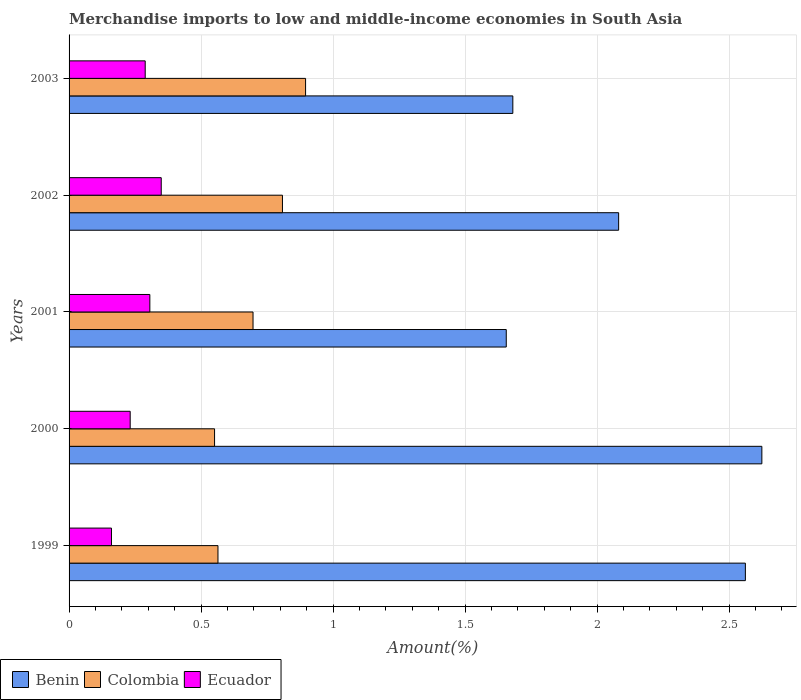How many different coloured bars are there?
Your response must be concise. 3. Are the number of bars per tick equal to the number of legend labels?
Your response must be concise. Yes. Are the number of bars on each tick of the Y-axis equal?
Offer a very short reply. Yes. How many bars are there on the 2nd tick from the bottom?
Give a very brief answer. 3. What is the label of the 1st group of bars from the top?
Offer a terse response. 2003. What is the percentage of amount earned from merchandise imports in Colombia in 2001?
Offer a terse response. 0.7. Across all years, what is the maximum percentage of amount earned from merchandise imports in Ecuador?
Provide a succinct answer. 0.35. Across all years, what is the minimum percentage of amount earned from merchandise imports in Benin?
Offer a very short reply. 1.66. What is the total percentage of amount earned from merchandise imports in Benin in the graph?
Offer a terse response. 10.6. What is the difference between the percentage of amount earned from merchandise imports in Colombia in 1999 and that in 2000?
Make the answer very short. 0.01. What is the difference between the percentage of amount earned from merchandise imports in Colombia in 2003 and the percentage of amount earned from merchandise imports in Ecuador in 2002?
Keep it short and to the point. 0.55. What is the average percentage of amount earned from merchandise imports in Benin per year?
Your answer should be compact. 2.12. In the year 2001, what is the difference between the percentage of amount earned from merchandise imports in Benin and percentage of amount earned from merchandise imports in Colombia?
Provide a succinct answer. 0.96. What is the ratio of the percentage of amount earned from merchandise imports in Ecuador in 2001 to that in 2002?
Provide a short and direct response. 0.88. Is the percentage of amount earned from merchandise imports in Ecuador in 2000 less than that in 2003?
Ensure brevity in your answer.  Yes. Is the difference between the percentage of amount earned from merchandise imports in Benin in 2000 and 2003 greater than the difference between the percentage of amount earned from merchandise imports in Colombia in 2000 and 2003?
Your answer should be compact. Yes. What is the difference between the highest and the second highest percentage of amount earned from merchandise imports in Ecuador?
Give a very brief answer. 0.04. What is the difference between the highest and the lowest percentage of amount earned from merchandise imports in Benin?
Offer a very short reply. 0.97. In how many years, is the percentage of amount earned from merchandise imports in Benin greater than the average percentage of amount earned from merchandise imports in Benin taken over all years?
Your response must be concise. 2. Is the sum of the percentage of amount earned from merchandise imports in Colombia in 2000 and 2003 greater than the maximum percentage of amount earned from merchandise imports in Benin across all years?
Your response must be concise. No. What does the 1st bar from the top in 2001 represents?
Your answer should be very brief. Ecuador. What does the 3rd bar from the bottom in 2000 represents?
Provide a short and direct response. Ecuador. How many years are there in the graph?
Make the answer very short. 5. What is the difference between two consecutive major ticks on the X-axis?
Make the answer very short. 0.5. Does the graph contain grids?
Your answer should be compact. Yes. How are the legend labels stacked?
Provide a short and direct response. Horizontal. What is the title of the graph?
Offer a very short reply. Merchandise imports to low and middle-income economies in South Asia. Does "Mozambique" appear as one of the legend labels in the graph?
Your answer should be very brief. No. What is the label or title of the X-axis?
Keep it short and to the point. Amount(%). What is the label or title of the Y-axis?
Make the answer very short. Years. What is the Amount(%) of Benin in 1999?
Your answer should be compact. 2.56. What is the Amount(%) of Colombia in 1999?
Your answer should be very brief. 0.56. What is the Amount(%) in Ecuador in 1999?
Ensure brevity in your answer.  0.16. What is the Amount(%) in Benin in 2000?
Offer a very short reply. 2.62. What is the Amount(%) in Colombia in 2000?
Your answer should be very brief. 0.55. What is the Amount(%) in Ecuador in 2000?
Make the answer very short. 0.23. What is the Amount(%) in Benin in 2001?
Your answer should be very brief. 1.66. What is the Amount(%) in Colombia in 2001?
Your answer should be very brief. 0.7. What is the Amount(%) in Ecuador in 2001?
Offer a very short reply. 0.31. What is the Amount(%) of Benin in 2002?
Make the answer very short. 2.08. What is the Amount(%) in Colombia in 2002?
Your response must be concise. 0.81. What is the Amount(%) in Ecuador in 2002?
Keep it short and to the point. 0.35. What is the Amount(%) in Benin in 2003?
Offer a terse response. 1.68. What is the Amount(%) in Colombia in 2003?
Offer a terse response. 0.9. What is the Amount(%) in Ecuador in 2003?
Offer a terse response. 0.29. Across all years, what is the maximum Amount(%) in Benin?
Offer a terse response. 2.62. Across all years, what is the maximum Amount(%) in Colombia?
Ensure brevity in your answer.  0.9. Across all years, what is the maximum Amount(%) in Ecuador?
Ensure brevity in your answer.  0.35. Across all years, what is the minimum Amount(%) of Benin?
Provide a short and direct response. 1.66. Across all years, what is the minimum Amount(%) in Colombia?
Offer a very short reply. 0.55. Across all years, what is the minimum Amount(%) of Ecuador?
Provide a succinct answer. 0.16. What is the total Amount(%) in Benin in the graph?
Your answer should be compact. 10.6. What is the total Amount(%) of Colombia in the graph?
Provide a short and direct response. 3.52. What is the total Amount(%) of Ecuador in the graph?
Keep it short and to the point. 1.34. What is the difference between the Amount(%) in Benin in 1999 and that in 2000?
Provide a succinct answer. -0.06. What is the difference between the Amount(%) in Colombia in 1999 and that in 2000?
Your response must be concise. 0.01. What is the difference between the Amount(%) of Ecuador in 1999 and that in 2000?
Your answer should be very brief. -0.07. What is the difference between the Amount(%) of Benin in 1999 and that in 2001?
Offer a very short reply. 0.91. What is the difference between the Amount(%) of Colombia in 1999 and that in 2001?
Keep it short and to the point. -0.13. What is the difference between the Amount(%) in Ecuador in 1999 and that in 2001?
Keep it short and to the point. -0.15. What is the difference between the Amount(%) of Benin in 1999 and that in 2002?
Your response must be concise. 0.48. What is the difference between the Amount(%) of Colombia in 1999 and that in 2002?
Keep it short and to the point. -0.24. What is the difference between the Amount(%) of Ecuador in 1999 and that in 2002?
Make the answer very short. -0.19. What is the difference between the Amount(%) of Benin in 1999 and that in 2003?
Provide a short and direct response. 0.88. What is the difference between the Amount(%) of Colombia in 1999 and that in 2003?
Provide a succinct answer. -0.33. What is the difference between the Amount(%) of Ecuador in 1999 and that in 2003?
Provide a short and direct response. -0.13. What is the difference between the Amount(%) in Benin in 2000 and that in 2001?
Provide a short and direct response. 0.97. What is the difference between the Amount(%) of Colombia in 2000 and that in 2001?
Your answer should be compact. -0.15. What is the difference between the Amount(%) of Ecuador in 2000 and that in 2001?
Provide a short and direct response. -0.07. What is the difference between the Amount(%) of Benin in 2000 and that in 2002?
Offer a terse response. 0.54. What is the difference between the Amount(%) in Colombia in 2000 and that in 2002?
Your response must be concise. -0.26. What is the difference between the Amount(%) of Ecuador in 2000 and that in 2002?
Make the answer very short. -0.12. What is the difference between the Amount(%) of Benin in 2000 and that in 2003?
Ensure brevity in your answer.  0.94. What is the difference between the Amount(%) of Colombia in 2000 and that in 2003?
Give a very brief answer. -0.34. What is the difference between the Amount(%) in Ecuador in 2000 and that in 2003?
Your response must be concise. -0.06. What is the difference between the Amount(%) in Benin in 2001 and that in 2002?
Offer a very short reply. -0.43. What is the difference between the Amount(%) of Colombia in 2001 and that in 2002?
Give a very brief answer. -0.11. What is the difference between the Amount(%) in Ecuador in 2001 and that in 2002?
Provide a succinct answer. -0.04. What is the difference between the Amount(%) of Benin in 2001 and that in 2003?
Your answer should be very brief. -0.02. What is the difference between the Amount(%) in Colombia in 2001 and that in 2003?
Offer a terse response. -0.2. What is the difference between the Amount(%) of Ecuador in 2001 and that in 2003?
Provide a short and direct response. 0.02. What is the difference between the Amount(%) of Benin in 2002 and that in 2003?
Ensure brevity in your answer.  0.4. What is the difference between the Amount(%) in Colombia in 2002 and that in 2003?
Provide a short and direct response. -0.09. What is the difference between the Amount(%) of Ecuador in 2002 and that in 2003?
Your answer should be compact. 0.06. What is the difference between the Amount(%) in Benin in 1999 and the Amount(%) in Colombia in 2000?
Offer a terse response. 2.01. What is the difference between the Amount(%) of Benin in 1999 and the Amount(%) of Ecuador in 2000?
Your response must be concise. 2.33. What is the difference between the Amount(%) in Colombia in 1999 and the Amount(%) in Ecuador in 2000?
Your answer should be very brief. 0.33. What is the difference between the Amount(%) of Benin in 1999 and the Amount(%) of Colombia in 2001?
Provide a succinct answer. 1.86. What is the difference between the Amount(%) of Benin in 1999 and the Amount(%) of Ecuador in 2001?
Offer a terse response. 2.26. What is the difference between the Amount(%) in Colombia in 1999 and the Amount(%) in Ecuador in 2001?
Your answer should be very brief. 0.26. What is the difference between the Amount(%) of Benin in 1999 and the Amount(%) of Colombia in 2002?
Provide a succinct answer. 1.75. What is the difference between the Amount(%) in Benin in 1999 and the Amount(%) in Ecuador in 2002?
Offer a very short reply. 2.21. What is the difference between the Amount(%) in Colombia in 1999 and the Amount(%) in Ecuador in 2002?
Offer a very short reply. 0.21. What is the difference between the Amount(%) in Benin in 1999 and the Amount(%) in Colombia in 2003?
Ensure brevity in your answer.  1.67. What is the difference between the Amount(%) in Benin in 1999 and the Amount(%) in Ecuador in 2003?
Offer a very short reply. 2.27. What is the difference between the Amount(%) in Colombia in 1999 and the Amount(%) in Ecuador in 2003?
Your answer should be very brief. 0.28. What is the difference between the Amount(%) in Benin in 2000 and the Amount(%) in Colombia in 2001?
Keep it short and to the point. 1.93. What is the difference between the Amount(%) in Benin in 2000 and the Amount(%) in Ecuador in 2001?
Offer a terse response. 2.32. What is the difference between the Amount(%) of Colombia in 2000 and the Amount(%) of Ecuador in 2001?
Offer a terse response. 0.25. What is the difference between the Amount(%) in Benin in 2000 and the Amount(%) in Colombia in 2002?
Your answer should be very brief. 1.82. What is the difference between the Amount(%) of Benin in 2000 and the Amount(%) of Ecuador in 2002?
Give a very brief answer. 2.27. What is the difference between the Amount(%) of Colombia in 2000 and the Amount(%) of Ecuador in 2002?
Provide a short and direct response. 0.2. What is the difference between the Amount(%) in Benin in 2000 and the Amount(%) in Colombia in 2003?
Your answer should be compact. 1.73. What is the difference between the Amount(%) in Benin in 2000 and the Amount(%) in Ecuador in 2003?
Your answer should be compact. 2.34. What is the difference between the Amount(%) in Colombia in 2000 and the Amount(%) in Ecuador in 2003?
Provide a short and direct response. 0.26. What is the difference between the Amount(%) in Benin in 2001 and the Amount(%) in Colombia in 2002?
Give a very brief answer. 0.85. What is the difference between the Amount(%) of Benin in 2001 and the Amount(%) of Ecuador in 2002?
Offer a terse response. 1.31. What is the difference between the Amount(%) in Colombia in 2001 and the Amount(%) in Ecuador in 2002?
Provide a succinct answer. 0.35. What is the difference between the Amount(%) in Benin in 2001 and the Amount(%) in Colombia in 2003?
Keep it short and to the point. 0.76. What is the difference between the Amount(%) in Benin in 2001 and the Amount(%) in Ecuador in 2003?
Offer a very short reply. 1.37. What is the difference between the Amount(%) in Colombia in 2001 and the Amount(%) in Ecuador in 2003?
Your answer should be very brief. 0.41. What is the difference between the Amount(%) in Benin in 2002 and the Amount(%) in Colombia in 2003?
Ensure brevity in your answer.  1.19. What is the difference between the Amount(%) of Benin in 2002 and the Amount(%) of Ecuador in 2003?
Make the answer very short. 1.79. What is the difference between the Amount(%) in Colombia in 2002 and the Amount(%) in Ecuador in 2003?
Offer a terse response. 0.52. What is the average Amount(%) of Benin per year?
Your response must be concise. 2.12. What is the average Amount(%) of Colombia per year?
Offer a terse response. 0.7. What is the average Amount(%) of Ecuador per year?
Offer a terse response. 0.27. In the year 1999, what is the difference between the Amount(%) of Benin and Amount(%) of Colombia?
Provide a succinct answer. 2. In the year 1999, what is the difference between the Amount(%) of Benin and Amount(%) of Ecuador?
Your response must be concise. 2.4. In the year 1999, what is the difference between the Amount(%) in Colombia and Amount(%) in Ecuador?
Your response must be concise. 0.4. In the year 2000, what is the difference between the Amount(%) of Benin and Amount(%) of Colombia?
Your answer should be compact. 2.07. In the year 2000, what is the difference between the Amount(%) in Benin and Amount(%) in Ecuador?
Provide a short and direct response. 2.39. In the year 2000, what is the difference between the Amount(%) of Colombia and Amount(%) of Ecuador?
Ensure brevity in your answer.  0.32. In the year 2001, what is the difference between the Amount(%) of Benin and Amount(%) of Ecuador?
Ensure brevity in your answer.  1.35. In the year 2001, what is the difference between the Amount(%) in Colombia and Amount(%) in Ecuador?
Offer a terse response. 0.39. In the year 2002, what is the difference between the Amount(%) in Benin and Amount(%) in Colombia?
Give a very brief answer. 1.27. In the year 2002, what is the difference between the Amount(%) of Benin and Amount(%) of Ecuador?
Ensure brevity in your answer.  1.73. In the year 2002, what is the difference between the Amount(%) in Colombia and Amount(%) in Ecuador?
Make the answer very short. 0.46. In the year 2003, what is the difference between the Amount(%) of Benin and Amount(%) of Colombia?
Your answer should be very brief. 0.78. In the year 2003, what is the difference between the Amount(%) in Benin and Amount(%) in Ecuador?
Your answer should be very brief. 1.39. In the year 2003, what is the difference between the Amount(%) in Colombia and Amount(%) in Ecuador?
Offer a terse response. 0.61. What is the ratio of the Amount(%) in Benin in 1999 to that in 2000?
Provide a short and direct response. 0.98. What is the ratio of the Amount(%) of Colombia in 1999 to that in 2000?
Offer a terse response. 1.02. What is the ratio of the Amount(%) in Ecuador in 1999 to that in 2000?
Offer a very short reply. 0.69. What is the ratio of the Amount(%) of Benin in 1999 to that in 2001?
Provide a short and direct response. 1.55. What is the ratio of the Amount(%) of Colombia in 1999 to that in 2001?
Provide a succinct answer. 0.81. What is the ratio of the Amount(%) in Ecuador in 1999 to that in 2001?
Ensure brevity in your answer.  0.52. What is the ratio of the Amount(%) in Benin in 1999 to that in 2002?
Provide a succinct answer. 1.23. What is the ratio of the Amount(%) of Colombia in 1999 to that in 2002?
Offer a very short reply. 0.7. What is the ratio of the Amount(%) in Ecuador in 1999 to that in 2002?
Provide a short and direct response. 0.46. What is the ratio of the Amount(%) of Benin in 1999 to that in 2003?
Ensure brevity in your answer.  1.52. What is the ratio of the Amount(%) in Colombia in 1999 to that in 2003?
Provide a short and direct response. 0.63. What is the ratio of the Amount(%) in Ecuador in 1999 to that in 2003?
Give a very brief answer. 0.56. What is the ratio of the Amount(%) of Benin in 2000 to that in 2001?
Give a very brief answer. 1.58. What is the ratio of the Amount(%) of Colombia in 2000 to that in 2001?
Your answer should be compact. 0.79. What is the ratio of the Amount(%) of Ecuador in 2000 to that in 2001?
Ensure brevity in your answer.  0.76. What is the ratio of the Amount(%) of Benin in 2000 to that in 2002?
Your answer should be very brief. 1.26. What is the ratio of the Amount(%) of Colombia in 2000 to that in 2002?
Offer a very short reply. 0.68. What is the ratio of the Amount(%) in Ecuador in 2000 to that in 2002?
Your answer should be compact. 0.66. What is the ratio of the Amount(%) in Benin in 2000 to that in 2003?
Your response must be concise. 1.56. What is the ratio of the Amount(%) of Colombia in 2000 to that in 2003?
Your answer should be compact. 0.62. What is the ratio of the Amount(%) in Ecuador in 2000 to that in 2003?
Your answer should be very brief. 0.8. What is the ratio of the Amount(%) in Benin in 2001 to that in 2002?
Your response must be concise. 0.8. What is the ratio of the Amount(%) of Colombia in 2001 to that in 2002?
Ensure brevity in your answer.  0.86. What is the ratio of the Amount(%) in Ecuador in 2001 to that in 2002?
Keep it short and to the point. 0.88. What is the ratio of the Amount(%) in Benin in 2001 to that in 2003?
Your answer should be compact. 0.99. What is the ratio of the Amount(%) in Colombia in 2001 to that in 2003?
Make the answer very short. 0.78. What is the ratio of the Amount(%) of Ecuador in 2001 to that in 2003?
Offer a terse response. 1.06. What is the ratio of the Amount(%) of Benin in 2002 to that in 2003?
Offer a terse response. 1.24. What is the ratio of the Amount(%) of Colombia in 2002 to that in 2003?
Offer a very short reply. 0.9. What is the ratio of the Amount(%) of Ecuador in 2002 to that in 2003?
Your answer should be compact. 1.21. What is the difference between the highest and the second highest Amount(%) in Benin?
Provide a succinct answer. 0.06. What is the difference between the highest and the second highest Amount(%) in Colombia?
Make the answer very short. 0.09. What is the difference between the highest and the second highest Amount(%) of Ecuador?
Provide a short and direct response. 0.04. What is the difference between the highest and the lowest Amount(%) of Colombia?
Your answer should be very brief. 0.34. What is the difference between the highest and the lowest Amount(%) of Ecuador?
Provide a short and direct response. 0.19. 